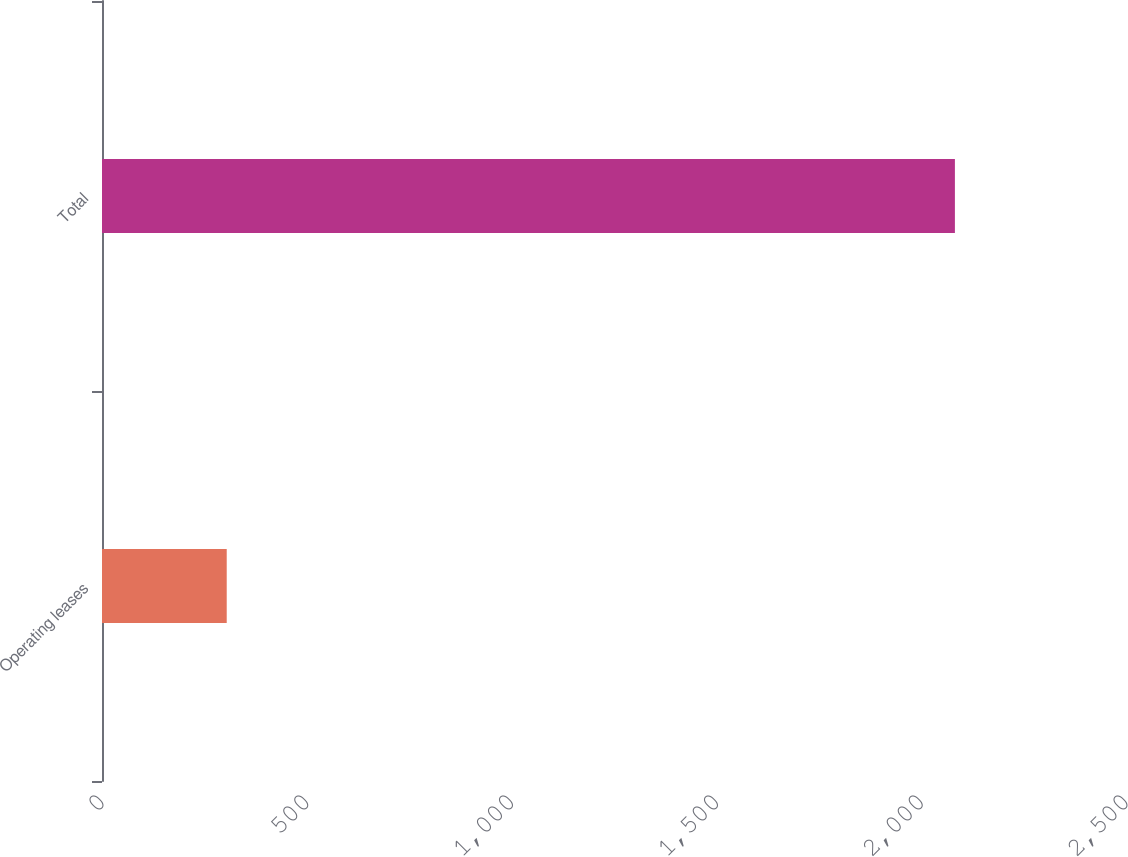Convert chart. <chart><loc_0><loc_0><loc_500><loc_500><bar_chart><fcel>Operating leases<fcel>Total<nl><fcel>304.5<fcel>2082.3<nl></chart> 